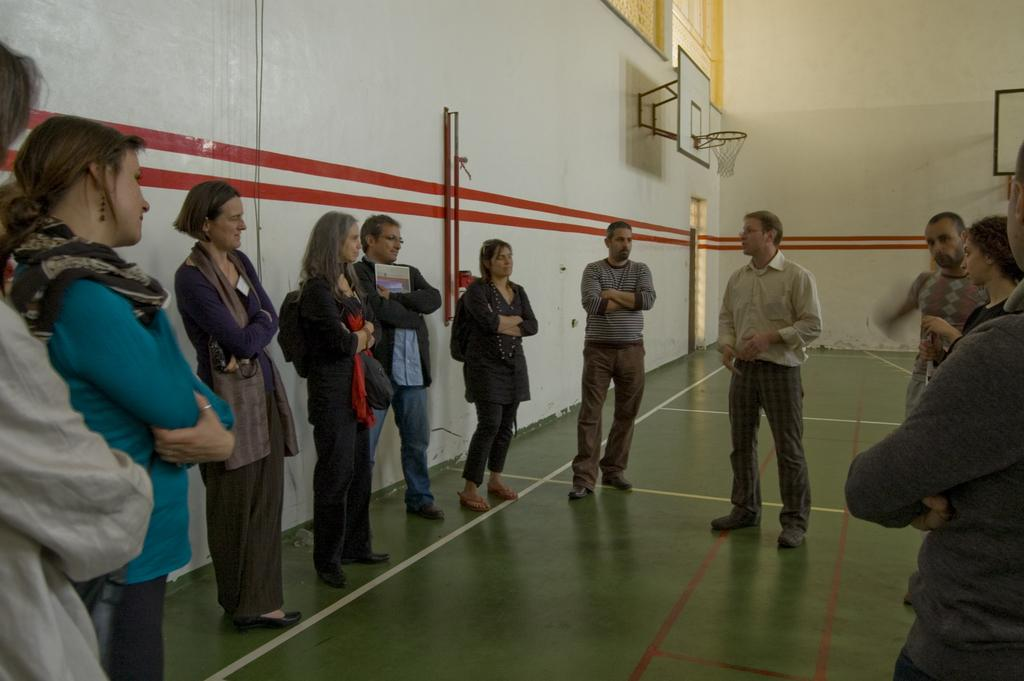How many people are visible in the image? There are many people standing in the image. What can be seen on the wall in the image? There is a board with a basketball net on the wall. Can you describe the lady on the left side of the image? The lady on the left side of the image is wearing a scarf. What emotion does the lady on the left side of the image express towards her past decisions? The image does not provide information about the lady's emotions or past decisions, so we cannot determine her feelings of regret. 